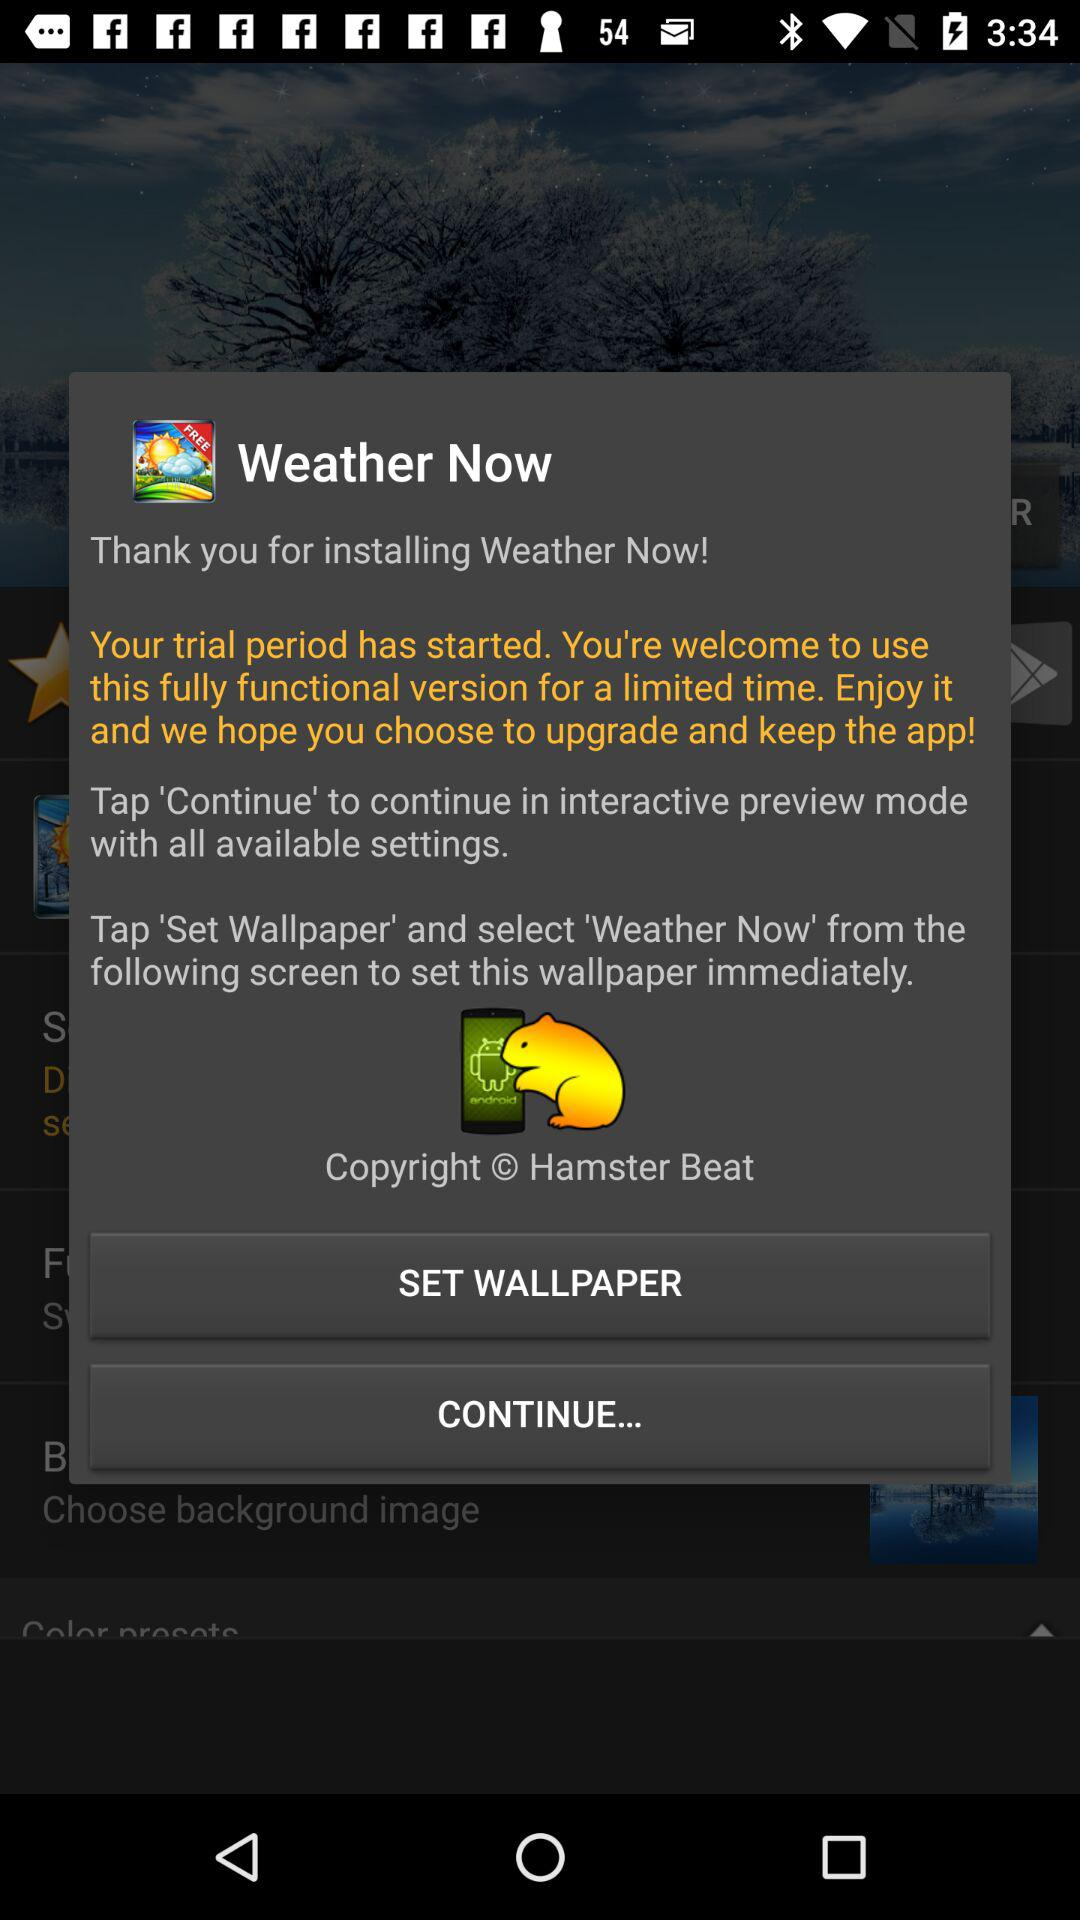What is the application name? The name of the application is "Weather Now". 